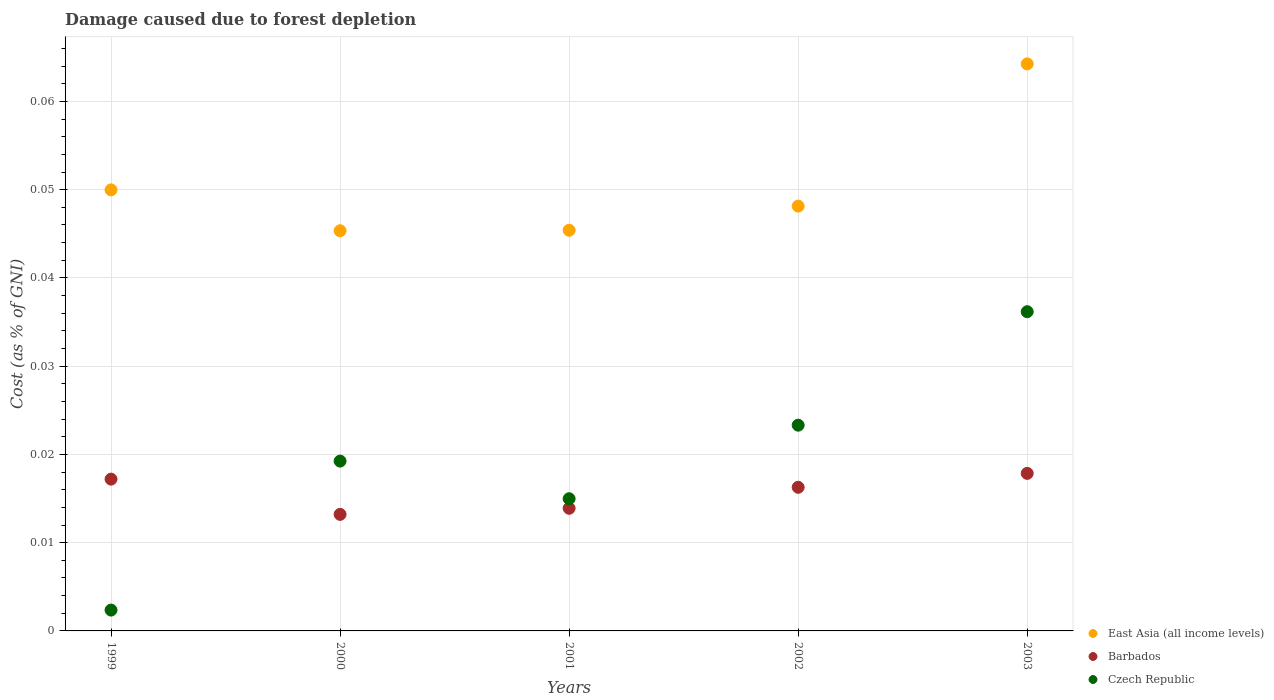How many different coloured dotlines are there?
Provide a short and direct response. 3. What is the cost of damage caused due to forest depletion in Czech Republic in 1999?
Your answer should be compact. 0. Across all years, what is the maximum cost of damage caused due to forest depletion in Barbados?
Keep it short and to the point. 0.02. Across all years, what is the minimum cost of damage caused due to forest depletion in Czech Republic?
Make the answer very short. 0. What is the total cost of damage caused due to forest depletion in East Asia (all income levels) in the graph?
Your answer should be compact. 0.25. What is the difference between the cost of damage caused due to forest depletion in Czech Republic in 2001 and that in 2002?
Provide a short and direct response. -0.01. What is the difference between the cost of damage caused due to forest depletion in Czech Republic in 2003 and the cost of damage caused due to forest depletion in Barbados in 2001?
Give a very brief answer. 0.02. What is the average cost of damage caused due to forest depletion in Barbados per year?
Your response must be concise. 0.02. In the year 2003, what is the difference between the cost of damage caused due to forest depletion in East Asia (all income levels) and cost of damage caused due to forest depletion in Czech Republic?
Provide a short and direct response. 0.03. What is the ratio of the cost of damage caused due to forest depletion in Barbados in 1999 to that in 2001?
Your answer should be very brief. 1.24. Is the cost of damage caused due to forest depletion in Czech Republic in 1999 less than that in 2002?
Provide a succinct answer. Yes. What is the difference between the highest and the second highest cost of damage caused due to forest depletion in Barbados?
Provide a short and direct response. 0. What is the difference between the highest and the lowest cost of damage caused due to forest depletion in East Asia (all income levels)?
Provide a succinct answer. 0.02. In how many years, is the cost of damage caused due to forest depletion in Czech Republic greater than the average cost of damage caused due to forest depletion in Czech Republic taken over all years?
Offer a terse response. 3. Is the sum of the cost of damage caused due to forest depletion in Czech Republic in 2001 and 2002 greater than the maximum cost of damage caused due to forest depletion in East Asia (all income levels) across all years?
Your answer should be compact. No. Is the cost of damage caused due to forest depletion in East Asia (all income levels) strictly greater than the cost of damage caused due to forest depletion in Barbados over the years?
Make the answer very short. Yes. How many dotlines are there?
Provide a succinct answer. 3. Are the values on the major ticks of Y-axis written in scientific E-notation?
Your answer should be compact. No. Where does the legend appear in the graph?
Your response must be concise. Bottom right. How are the legend labels stacked?
Offer a terse response. Vertical. What is the title of the graph?
Provide a succinct answer. Damage caused due to forest depletion. Does "Congo (Democratic)" appear as one of the legend labels in the graph?
Offer a very short reply. No. What is the label or title of the X-axis?
Your answer should be very brief. Years. What is the label or title of the Y-axis?
Your answer should be very brief. Cost (as % of GNI). What is the Cost (as % of GNI) of East Asia (all income levels) in 1999?
Your answer should be very brief. 0.05. What is the Cost (as % of GNI) of Barbados in 1999?
Your response must be concise. 0.02. What is the Cost (as % of GNI) of Czech Republic in 1999?
Your response must be concise. 0. What is the Cost (as % of GNI) of East Asia (all income levels) in 2000?
Provide a short and direct response. 0.05. What is the Cost (as % of GNI) of Barbados in 2000?
Your response must be concise. 0.01. What is the Cost (as % of GNI) in Czech Republic in 2000?
Ensure brevity in your answer.  0.02. What is the Cost (as % of GNI) of East Asia (all income levels) in 2001?
Keep it short and to the point. 0.05. What is the Cost (as % of GNI) of Barbados in 2001?
Your answer should be compact. 0.01. What is the Cost (as % of GNI) in Czech Republic in 2001?
Offer a very short reply. 0.01. What is the Cost (as % of GNI) of East Asia (all income levels) in 2002?
Ensure brevity in your answer.  0.05. What is the Cost (as % of GNI) of Barbados in 2002?
Give a very brief answer. 0.02. What is the Cost (as % of GNI) in Czech Republic in 2002?
Offer a very short reply. 0.02. What is the Cost (as % of GNI) in East Asia (all income levels) in 2003?
Your answer should be compact. 0.06. What is the Cost (as % of GNI) in Barbados in 2003?
Make the answer very short. 0.02. What is the Cost (as % of GNI) of Czech Republic in 2003?
Your answer should be very brief. 0.04. Across all years, what is the maximum Cost (as % of GNI) in East Asia (all income levels)?
Keep it short and to the point. 0.06. Across all years, what is the maximum Cost (as % of GNI) in Barbados?
Ensure brevity in your answer.  0.02. Across all years, what is the maximum Cost (as % of GNI) in Czech Republic?
Your response must be concise. 0.04. Across all years, what is the minimum Cost (as % of GNI) in East Asia (all income levels)?
Keep it short and to the point. 0.05. Across all years, what is the minimum Cost (as % of GNI) in Barbados?
Your response must be concise. 0.01. Across all years, what is the minimum Cost (as % of GNI) of Czech Republic?
Your response must be concise. 0. What is the total Cost (as % of GNI) of East Asia (all income levels) in the graph?
Ensure brevity in your answer.  0.25. What is the total Cost (as % of GNI) in Barbados in the graph?
Your response must be concise. 0.08. What is the total Cost (as % of GNI) of Czech Republic in the graph?
Provide a short and direct response. 0.1. What is the difference between the Cost (as % of GNI) in East Asia (all income levels) in 1999 and that in 2000?
Your answer should be very brief. 0. What is the difference between the Cost (as % of GNI) of Barbados in 1999 and that in 2000?
Your response must be concise. 0. What is the difference between the Cost (as % of GNI) in Czech Republic in 1999 and that in 2000?
Offer a very short reply. -0.02. What is the difference between the Cost (as % of GNI) in East Asia (all income levels) in 1999 and that in 2001?
Your answer should be compact. 0. What is the difference between the Cost (as % of GNI) in Barbados in 1999 and that in 2001?
Ensure brevity in your answer.  0. What is the difference between the Cost (as % of GNI) of Czech Republic in 1999 and that in 2001?
Offer a terse response. -0.01. What is the difference between the Cost (as % of GNI) of East Asia (all income levels) in 1999 and that in 2002?
Your answer should be very brief. 0. What is the difference between the Cost (as % of GNI) of Barbados in 1999 and that in 2002?
Provide a succinct answer. 0. What is the difference between the Cost (as % of GNI) of Czech Republic in 1999 and that in 2002?
Keep it short and to the point. -0.02. What is the difference between the Cost (as % of GNI) in East Asia (all income levels) in 1999 and that in 2003?
Your answer should be very brief. -0.01. What is the difference between the Cost (as % of GNI) of Barbados in 1999 and that in 2003?
Your answer should be compact. -0. What is the difference between the Cost (as % of GNI) of Czech Republic in 1999 and that in 2003?
Make the answer very short. -0.03. What is the difference between the Cost (as % of GNI) of East Asia (all income levels) in 2000 and that in 2001?
Give a very brief answer. -0. What is the difference between the Cost (as % of GNI) of Barbados in 2000 and that in 2001?
Offer a very short reply. -0. What is the difference between the Cost (as % of GNI) in Czech Republic in 2000 and that in 2001?
Keep it short and to the point. 0. What is the difference between the Cost (as % of GNI) of East Asia (all income levels) in 2000 and that in 2002?
Your answer should be compact. -0. What is the difference between the Cost (as % of GNI) of Barbados in 2000 and that in 2002?
Keep it short and to the point. -0. What is the difference between the Cost (as % of GNI) of Czech Republic in 2000 and that in 2002?
Your answer should be compact. -0. What is the difference between the Cost (as % of GNI) in East Asia (all income levels) in 2000 and that in 2003?
Provide a short and direct response. -0.02. What is the difference between the Cost (as % of GNI) of Barbados in 2000 and that in 2003?
Your answer should be compact. -0. What is the difference between the Cost (as % of GNI) of Czech Republic in 2000 and that in 2003?
Provide a short and direct response. -0.02. What is the difference between the Cost (as % of GNI) of East Asia (all income levels) in 2001 and that in 2002?
Offer a very short reply. -0. What is the difference between the Cost (as % of GNI) of Barbados in 2001 and that in 2002?
Make the answer very short. -0. What is the difference between the Cost (as % of GNI) in Czech Republic in 2001 and that in 2002?
Keep it short and to the point. -0.01. What is the difference between the Cost (as % of GNI) of East Asia (all income levels) in 2001 and that in 2003?
Your answer should be compact. -0.02. What is the difference between the Cost (as % of GNI) of Barbados in 2001 and that in 2003?
Your answer should be compact. -0. What is the difference between the Cost (as % of GNI) of Czech Republic in 2001 and that in 2003?
Offer a very short reply. -0.02. What is the difference between the Cost (as % of GNI) in East Asia (all income levels) in 2002 and that in 2003?
Give a very brief answer. -0.02. What is the difference between the Cost (as % of GNI) of Barbados in 2002 and that in 2003?
Provide a succinct answer. -0. What is the difference between the Cost (as % of GNI) of Czech Republic in 2002 and that in 2003?
Give a very brief answer. -0.01. What is the difference between the Cost (as % of GNI) in East Asia (all income levels) in 1999 and the Cost (as % of GNI) in Barbados in 2000?
Offer a terse response. 0.04. What is the difference between the Cost (as % of GNI) in East Asia (all income levels) in 1999 and the Cost (as % of GNI) in Czech Republic in 2000?
Offer a very short reply. 0.03. What is the difference between the Cost (as % of GNI) in Barbados in 1999 and the Cost (as % of GNI) in Czech Republic in 2000?
Provide a succinct answer. -0. What is the difference between the Cost (as % of GNI) of East Asia (all income levels) in 1999 and the Cost (as % of GNI) of Barbados in 2001?
Offer a very short reply. 0.04. What is the difference between the Cost (as % of GNI) in East Asia (all income levels) in 1999 and the Cost (as % of GNI) in Czech Republic in 2001?
Your answer should be very brief. 0.04. What is the difference between the Cost (as % of GNI) in Barbados in 1999 and the Cost (as % of GNI) in Czech Republic in 2001?
Your answer should be very brief. 0. What is the difference between the Cost (as % of GNI) in East Asia (all income levels) in 1999 and the Cost (as % of GNI) in Barbados in 2002?
Ensure brevity in your answer.  0.03. What is the difference between the Cost (as % of GNI) of East Asia (all income levels) in 1999 and the Cost (as % of GNI) of Czech Republic in 2002?
Keep it short and to the point. 0.03. What is the difference between the Cost (as % of GNI) of Barbados in 1999 and the Cost (as % of GNI) of Czech Republic in 2002?
Provide a short and direct response. -0.01. What is the difference between the Cost (as % of GNI) of East Asia (all income levels) in 1999 and the Cost (as % of GNI) of Barbados in 2003?
Keep it short and to the point. 0.03. What is the difference between the Cost (as % of GNI) of East Asia (all income levels) in 1999 and the Cost (as % of GNI) of Czech Republic in 2003?
Offer a terse response. 0.01. What is the difference between the Cost (as % of GNI) in Barbados in 1999 and the Cost (as % of GNI) in Czech Republic in 2003?
Your answer should be very brief. -0.02. What is the difference between the Cost (as % of GNI) in East Asia (all income levels) in 2000 and the Cost (as % of GNI) in Barbados in 2001?
Offer a terse response. 0.03. What is the difference between the Cost (as % of GNI) of East Asia (all income levels) in 2000 and the Cost (as % of GNI) of Czech Republic in 2001?
Your answer should be compact. 0.03. What is the difference between the Cost (as % of GNI) in Barbados in 2000 and the Cost (as % of GNI) in Czech Republic in 2001?
Give a very brief answer. -0. What is the difference between the Cost (as % of GNI) of East Asia (all income levels) in 2000 and the Cost (as % of GNI) of Barbados in 2002?
Ensure brevity in your answer.  0.03. What is the difference between the Cost (as % of GNI) in East Asia (all income levels) in 2000 and the Cost (as % of GNI) in Czech Republic in 2002?
Your response must be concise. 0.02. What is the difference between the Cost (as % of GNI) in Barbados in 2000 and the Cost (as % of GNI) in Czech Republic in 2002?
Keep it short and to the point. -0.01. What is the difference between the Cost (as % of GNI) of East Asia (all income levels) in 2000 and the Cost (as % of GNI) of Barbados in 2003?
Ensure brevity in your answer.  0.03. What is the difference between the Cost (as % of GNI) in East Asia (all income levels) in 2000 and the Cost (as % of GNI) in Czech Republic in 2003?
Offer a terse response. 0.01. What is the difference between the Cost (as % of GNI) in Barbados in 2000 and the Cost (as % of GNI) in Czech Republic in 2003?
Provide a succinct answer. -0.02. What is the difference between the Cost (as % of GNI) of East Asia (all income levels) in 2001 and the Cost (as % of GNI) of Barbados in 2002?
Offer a terse response. 0.03. What is the difference between the Cost (as % of GNI) in East Asia (all income levels) in 2001 and the Cost (as % of GNI) in Czech Republic in 2002?
Your response must be concise. 0.02. What is the difference between the Cost (as % of GNI) of Barbados in 2001 and the Cost (as % of GNI) of Czech Republic in 2002?
Make the answer very short. -0.01. What is the difference between the Cost (as % of GNI) in East Asia (all income levels) in 2001 and the Cost (as % of GNI) in Barbados in 2003?
Provide a short and direct response. 0.03. What is the difference between the Cost (as % of GNI) of East Asia (all income levels) in 2001 and the Cost (as % of GNI) of Czech Republic in 2003?
Offer a very short reply. 0.01. What is the difference between the Cost (as % of GNI) of Barbados in 2001 and the Cost (as % of GNI) of Czech Republic in 2003?
Ensure brevity in your answer.  -0.02. What is the difference between the Cost (as % of GNI) in East Asia (all income levels) in 2002 and the Cost (as % of GNI) in Barbados in 2003?
Your answer should be very brief. 0.03. What is the difference between the Cost (as % of GNI) in East Asia (all income levels) in 2002 and the Cost (as % of GNI) in Czech Republic in 2003?
Your response must be concise. 0.01. What is the difference between the Cost (as % of GNI) of Barbados in 2002 and the Cost (as % of GNI) of Czech Republic in 2003?
Your response must be concise. -0.02. What is the average Cost (as % of GNI) of East Asia (all income levels) per year?
Make the answer very short. 0.05. What is the average Cost (as % of GNI) in Barbados per year?
Ensure brevity in your answer.  0.02. What is the average Cost (as % of GNI) in Czech Republic per year?
Ensure brevity in your answer.  0.02. In the year 1999, what is the difference between the Cost (as % of GNI) of East Asia (all income levels) and Cost (as % of GNI) of Barbados?
Keep it short and to the point. 0.03. In the year 1999, what is the difference between the Cost (as % of GNI) in East Asia (all income levels) and Cost (as % of GNI) in Czech Republic?
Your response must be concise. 0.05. In the year 1999, what is the difference between the Cost (as % of GNI) in Barbados and Cost (as % of GNI) in Czech Republic?
Make the answer very short. 0.01. In the year 2000, what is the difference between the Cost (as % of GNI) in East Asia (all income levels) and Cost (as % of GNI) in Barbados?
Provide a short and direct response. 0.03. In the year 2000, what is the difference between the Cost (as % of GNI) in East Asia (all income levels) and Cost (as % of GNI) in Czech Republic?
Your answer should be compact. 0.03. In the year 2000, what is the difference between the Cost (as % of GNI) of Barbados and Cost (as % of GNI) of Czech Republic?
Provide a short and direct response. -0.01. In the year 2001, what is the difference between the Cost (as % of GNI) in East Asia (all income levels) and Cost (as % of GNI) in Barbados?
Your response must be concise. 0.03. In the year 2001, what is the difference between the Cost (as % of GNI) of East Asia (all income levels) and Cost (as % of GNI) of Czech Republic?
Provide a short and direct response. 0.03. In the year 2001, what is the difference between the Cost (as % of GNI) of Barbados and Cost (as % of GNI) of Czech Republic?
Your answer should be very brief. -0. In the year 2002, what is the difference between the Cost (as % of GNI) in East Asia (all income levels) and Cost (as % of GNI) in Barbados?
Offer a very short reply. 0.03. In the year 2002, what is the difference between the Cost (as % of GNI) in East Asia (all income levels) and Cost (as % of GNI) in Czech Republic?
Ensure brevity in your answer.  0.02. In the year 2002, what is the difference between the Cost (as % of GNI) of Barbados and Cost (as % of GNI) of Czech Republic?
Your answer should be compact. -0.01. In the year 2003, what is the difference between the Cost (as % of GNI) of East Asia (all income levels) and Cost (as % of GNI) of Barbados?
Provide a short and direct response. 0.05. In the year 2003, what is the difference between the Cost (as % of GNI) in East Asia (all income levels) and Cost (as % of GNI) in Czech Republic?
Your answer should be compact. 0.03. In the year 2003, what is the difference between the Cost (as % of GNI) in Barbados and Cost (as % of GNI) in Czech Republic?
Offer a very short reply. -0.02. What is the ratio of the Cost (as % of GNI) of East Asia (all income levels) in 1999 to that in 2000?
Your response must be concise. 1.1. What is the ratio of the Cost (as % of GNI) of Barbados in 1999 to that in 2000?
Keep it short and to the point. 1.3. What is the ratio of the Cost (as % of GNI) in Czech Republic in 1999 to that in 2000?
Your answer should be compact. 0.12. What is the ratio of the Cost (as % of GNI) of East Asia (all income levels) in 1999 to that in 2001?
Provide a succinct answer. 1.1. What is the ratio of the Cost (as % of GNI) of Barbados in 1999 to that in 2001?
Give a very brief answer. 1.24. What is the ratio of the Cost (as % of GNI) in Czech Republic in 1999 to that in 2001?
Make the answer very short. 0.16. What is the ratio of the Cost (as % of GNI) of East Asia (all income levels) in 1999 to that in 2002?
Offer a terse response. 1.04. What is the ratio of the Cost (as % of GNI) of Barbados in 1999 to that in 2002?
Make the answer very short. 1.06. What is the ratio of the Cost (as % of GNI) in Czech Republic in 1999 to that in 2002?
Offer a terse response. 0.1. What is the ratio of the Cost (as % of GNI) of East Asia (all income levels) in 1999 to that in 2003?
Your response must be concise. 0.78. What is the ratio of the Cost (as % of GNI) in Barbados in 1999 to that in 2003?
Provide a succinct answer. 0.96. What is the ratio of the Cost (as % of GNI) of Czech Republic in 1999 to that in 2003?
Give a very brief answer. 0.07. What is the ratio of the Cost (as % of GNI) in East Asia (all income levels) in 2000 to that in 2001?
Make the answer very short. 1. What is the ratio of the Cost (as % of GNI) in Barbados in 2000 to that in 2001?
Your answer should be compact. 0.95. What is the ratio of the Cost (as % of GNI) of Czech Republic in 2000 to that in 2001?
Provide a succinct answer. 1.28. What is the ratio of the Cost (as % of GNI) in East Asia (all income levels) in 2000 to that in 2002?
Provide a succinct answer. 0.94. What is the ratio of the Cost (as % of GNI) of Barbados in 2000 to that in 2002?
Keep it short and to the point. 0.81. What is the ratio of the Cost (as % of GNI) of Czech Republic in 2000 to that in 2002?
Your answer should be compact. 0.83. What is the ratio of the Cost (as % of GNI) of East Asia (all income levels) in 2000 to that in 2003?
Your response must be concise. 0.71. What is the ratio of the Cost (as % of GNI) of Barbados in 2000 to that in 2003?
Keep it short and to the point. 0.74. What is the ratio of the Cost (as % of GNI) in Czech Republic in 2000 to that in 2003?
Make the answer very short. 0.53. What is the ratio of the Cost (as % of GNI) in East Asia (all income levels) in 2001 to that in 2002?
Your response must be concise. 0.94. What is the ratio of the Cost (as % of GNI) of Barbados in 2001 to that in 2002?
Ensure brevity in your answer.  0.85. What is the ratio of the Cost (as % of GNI) in Czech Republic in 2001 to that in 2002?
Your answer should be very brief. 0.64. What is the ratio of the Cost (as % of GNI) of East Asia (all income levels) in 2001 to that in 2003?
Ensure brevity in your answer.  0.71. What is the ratio of the Cost (as % of GNI) in Barbados in 2001 to that in 2003?
Ensure brevity in your answer.  0.78. What is the ratio of the Cost (as % of GNI) in Czech Republic in 2001 to that in 2003?
Make the answer very short. 0.41. What is the ratio of the Cost (as % of GNI) in East Asia (all income levels) in 2002 to that in 2003?
Your answer should be very brief. 0.75. What is the ratio of the Cost (as % of GNI) of Barbados in 2002 to that in 2003?
Ensure brevity in your answer.  0.91. What is the ratio of the Cost (as % of GNI) of Czech Republic in 2002 to that in 2003?
Provide a short and direct response. 0.64. What is the difference between the highest and the second highest Cost (as % of GNI) of East Asia (all income levels)?
Provide a succinct answer. 0.01. What is the difference between the highest and the second highest Cost (as % of GNI) of Barbados?
Your answer should be very brief. 0. What is the difference between the highest and the second highest Cost (as % of GNI) of Czech Republic?
Offer a very short reply. 0.01. What is the difference between the highest and the lowest Cost (as % of GNI) in East Asia (all income levels)?
Offer a terse response. 0.02. What is the difference between the highest and the lowest Cost (as % of GNI) of Barbados?
Your answer should be very brief. 0. What is the difference between the highest and the lowest Cost (as % of GNI) of Czech Republic?
Make the answer very short. 0.03. 